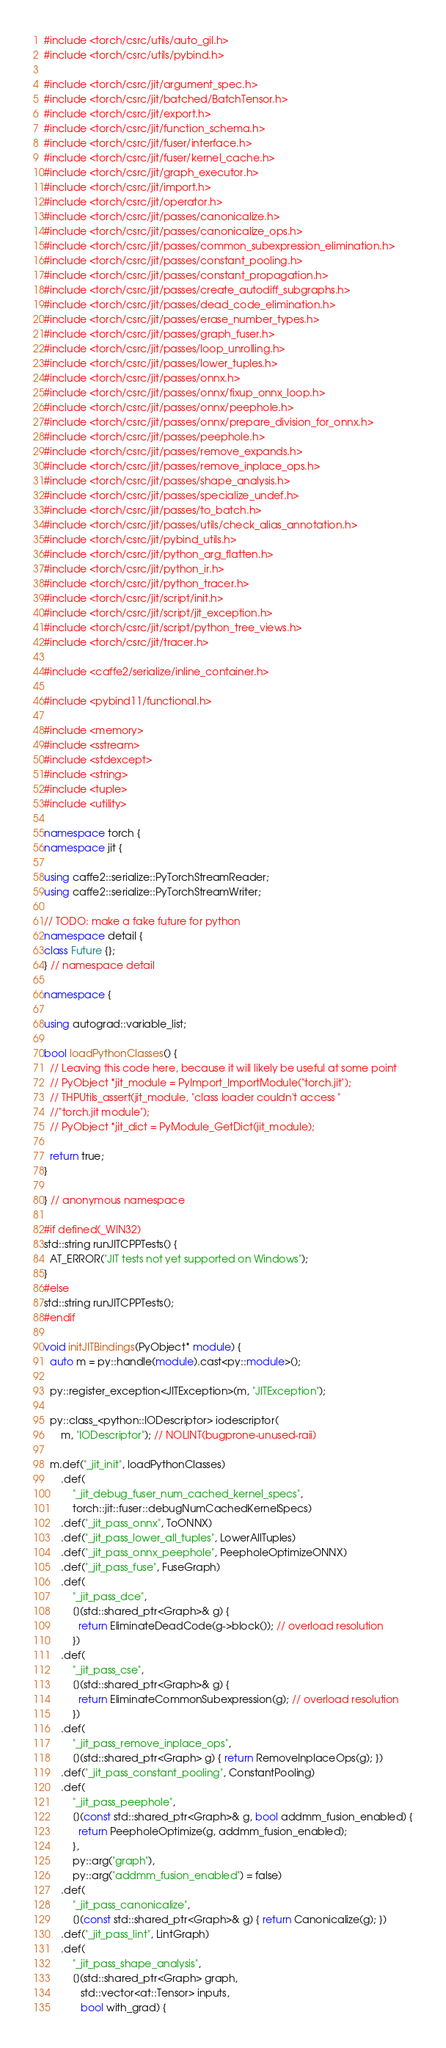<code> <loc_0><loc_0><loc_500><loc_500><_C++_>#include <torch/csrc/utils/auto_gil.h>
#include <torch/csrc/utils/pybind.h>

#include <torch/csrc/jit/argument_spec.h>
#include <torch/csrc/jit/batched/BatchTensor.h>
#include <torch/csrc/jit/export.h>
#include <torch/csrc/jit/function_schema.h>
#include <torch/csrc/jit/fuser/interface.h>
#include <torch/csrc/jit/fuser/kernel_cache.h>
#include <torch/csrc/jit/graph_executor.h>
#include <torch/csrc/jit/import.h>
#include <torch/csrc/jit/operator.h>
#include <torch/csrc/jit/passes/canonicalize.h>
#include <torch/csrc/jit/passes/canonicalize_ops.h>
#include <torch/csrc/jit/passes/common_subexpression_elimination.h>
#include <torch/csrc/jit/passes/constant_pooling.h>
#include <torch/csrc/jit/passes/constant_propagation.h>
#include <torch/csrc/jit/passes/create_autodiff_subgraphs.h>
#include <torch/csrc/jit/passes/dead_code_elimination.h>
#include <torch/csrc/jit/passes/erase_number_types.h>
#include <torch/csrc/jit/passes/graph_fuser.h>
#include <torch/csrc/jit/passes/loop_unrolling.h>
#include <torch/csrc/jit/passes/lower_tuples.h>
#include <torch/csrc/jit/passes/onnx.h>
#include <torch/csrc/jit/passes/onnx/fixup_onnx_loop.h>
#include <torch/csrc/jit/passes/onnx/peephole.h>
#include <torch/csrc/jit/passes/onnx/prepare_division_for_onnx.h>
#include <torch/csrc/jit/passes/peephole.h>
#include <torch/csrc/jit/passes/remove_expands.h>
#include <torch/csrc/jit/passes/remove_inplace_ops.h>
#include <torch/csrc/jit/passes/shape_analysis.h>
#include <torch/csrc/jit/passes/specialize_undef.h>
#include <torch/csrc/jit/passes/to_batch.h>
#include <torch/csrc/jit/passes/utils/check_alias_annotation.h>
#include <torch/csrc/jit/pybind_utils.h>
#include <torch/csrc/jit/python_arg_flatten.h>
#include <torch/csrc/jit/python_ir.h>
#include <torch/csrc/jit/python_tracer.h>
#include <torch/csrc/jit/script/init.h>
#include <torch/csrc/jit/script/jit_exception.h>
#include <torch/csrc/jit/script/python_tree_views.h>
#include <torch/csrc/jit/tracer.h>

#include <caffe2/serialize/inline_container.h>

#include <pybind11/functional.h>

#include <memory>
#include <sstream>
#include <stdexcept>
#include <string>
#include <tuple>
#include <utility>

namespace torch {
namespace jit {

using caffe2::serialize::PyTorchStreamReader;
using caffe2::serialize::PyTorchStreamWriter;

// TODO: make a fake future for python
namespace detail {
class Future {};
} // namespace detail

namespace {

using autograd::variable_list;

bool loadPythonClasses() {
  // Leaving this code here, because it will likely be useful at some point
  // PyObject *jit_module = PyImport_ImportModule("torch.jit");
  // THPUtils_assert(jit_module, "class loader couldn't access "
  //"torch.jit module");
  // PyObject *jit_dict = PyModule_GetDict(jit_module);

  return true;
}

} // anonymous namespace

#if defined(_WIN32)
std::string runJITCPPTests() {
  AT_ERROR("JIT tests not yet supported on Windows");
}
#else
std::string runJITCPPTests();
#endif

void initJITBindings(PyObject* module) {
  auto m = py::handle(module).cast<py::module>();

  py::register_exception<JITException>(m, "JITException");

  py::class_<python::IODescriptor> iodescriptor(
      m, "IODescriptor"); // NOLINT(bugprone-unused-raii)

  m.def("_jit_init", loadPythonClasses)
      .def(
          "_jit_debug_fuser_num_cached_kernel_specs",
          torch::jit::fuser::debugNumCachedKernelSpecs)
      .def("_jit_pass_onnx", ToONNX)
      .def("_jit_pass_lower_all_tuples", LowerAllTuples)
      .def("_jit_pass_onnx_peephole", PeepholeOptimizeONNX)
      .def("_jit_pass_fuse", FuseGraph)
      .def(
          "_jit_pass_dce",
          [](std::shared_ptr<Graph>& g) {
            return EliminateDeadCode(g->block()); // overload resolution
          })
      .def(
          "_jit_pass_cse",
          [](std::shared_ptr<Graph>& g) {
            return EliminateCommonSubexpression(g); // overload resolution
          })
      .def(
          "_jit_pass_remove_inplace_ops",
          [](std::shared_ptr<Graph> g) { return RemoveInplaceOps(g); })
      .def("_jit_pass_constant_pooling", ConstantPooling)
      .def(
          "_jit_pass_peephole",
          [](const std::shared_ptr<Graph>& g, bool addmm_fusion_enabled) {
            return PeepholeOptimize(g, addmm_fusion_enabled);
          },
          py::arg("graph"),
          py::arg("addmm_fusion_enabled") = false)
      .def(
          "_jit_pass_canonicalize",
          [](const std::shared_ptr<Graph>& g) { return Canonicalize(g); })
      .def("_jit_pass_lint", LintGraph)
      .def(
          "_jit_pass_shape_analysis",
          [](std::shared_ptr<Graph> graph,
             std::vector<at::Tensor> inputs,
             bool with_grad) {</code> 